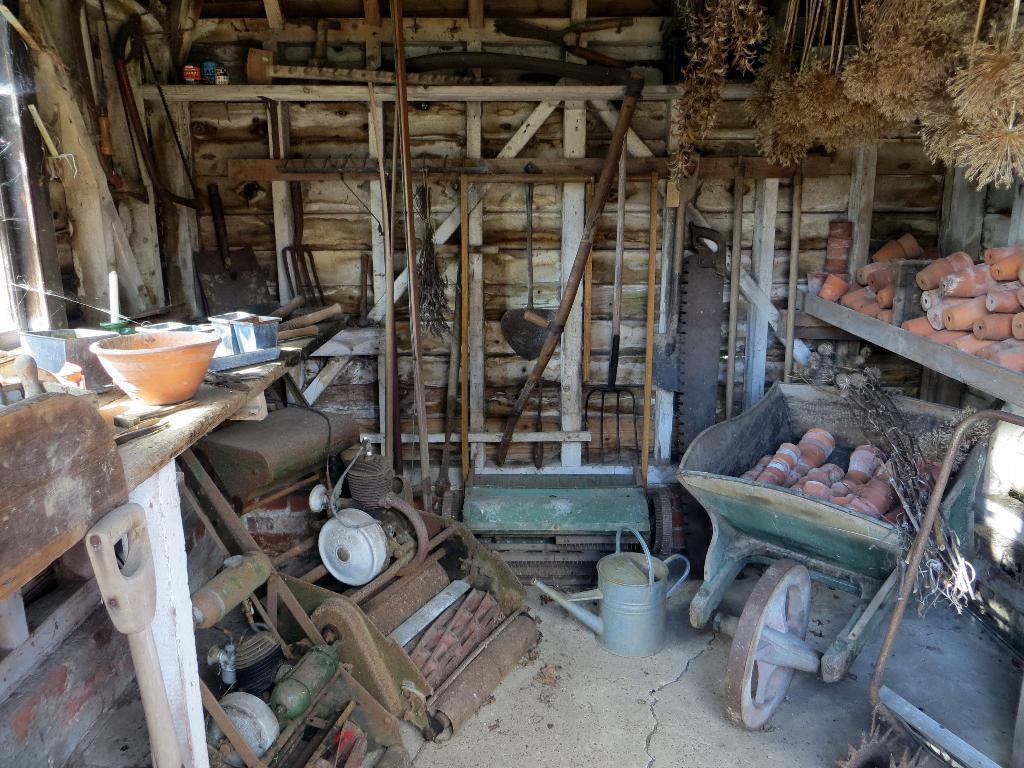Can you describe this image briefly? In the picture we can see some cut and some things placed in it and beside it, we can also see a rack and some things placed on it and we can also see some machinery on the path and top of it, we can see a wooden plank and some bowl and some things on it and in the background we can see a wall with wooden sticks. 